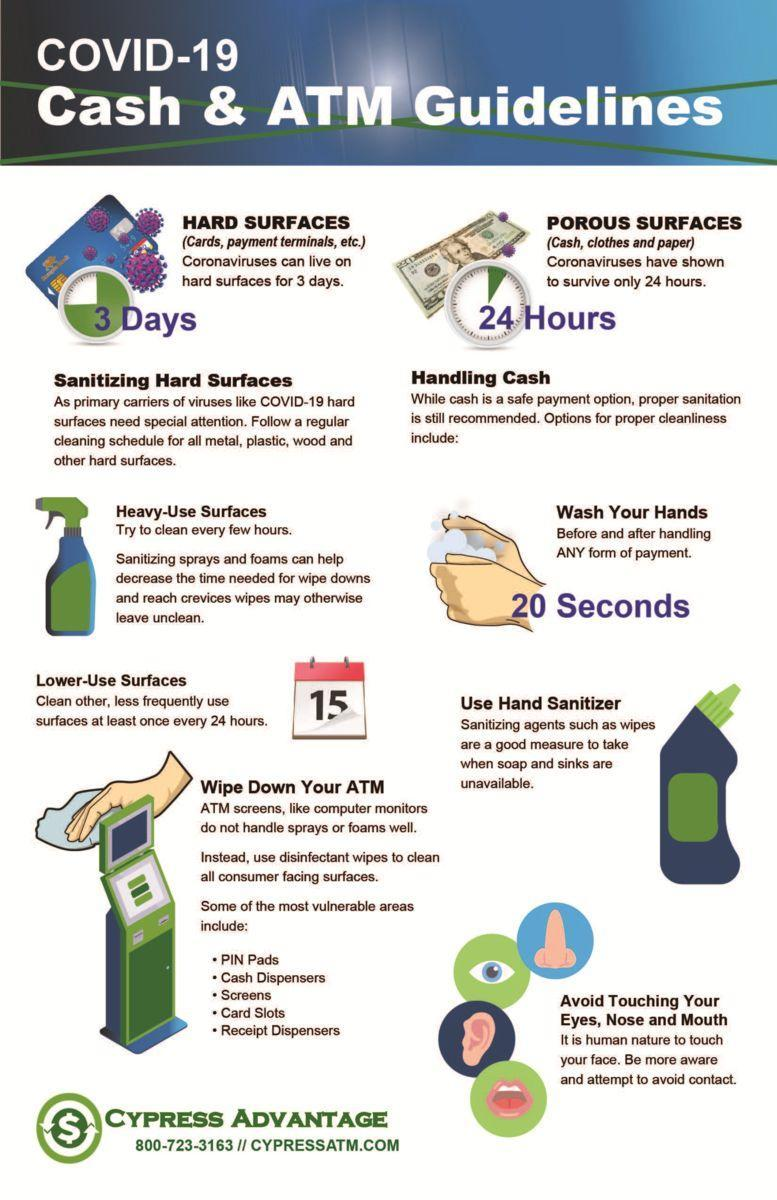What is the date shown on the calendar?
Answer the question with a short phrase. 15 How long the Covid-19 virus can stay on hard surfaces? 3 Days How long the Covid-19 virus can stay on porous surfaces? 24 HOURS How long one should wash their hands in order to prevent the spread of COVID-19? 20 Seconds 